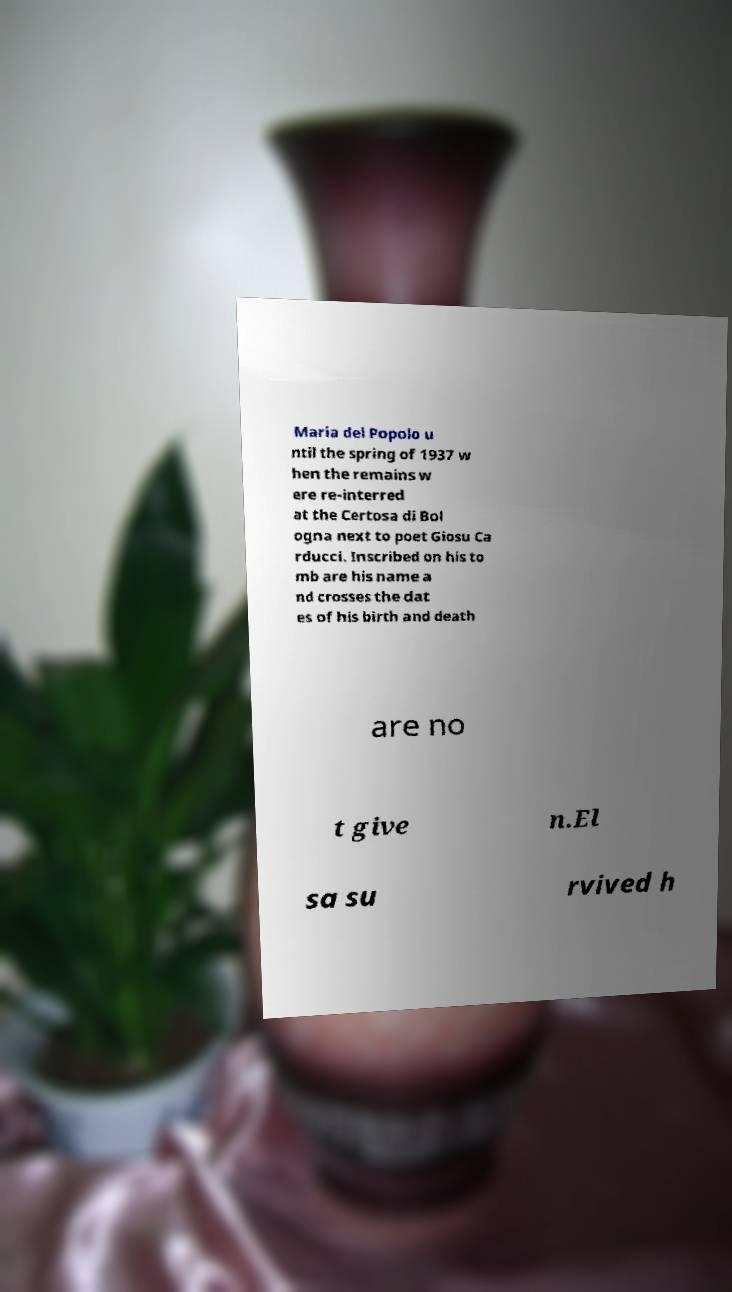Could you assist in decoding the text presented in this image and type it out clearly? Maria del Popolo u ntil the spring of 1937 w hen the remains w ere re-interred at the Certosa di Bol ogna next to poet Giosu Ca rducci. Inscribed on his to mb are his name a nd crosses the dat es of his birth and death are no t give n.El sa su rvived h 